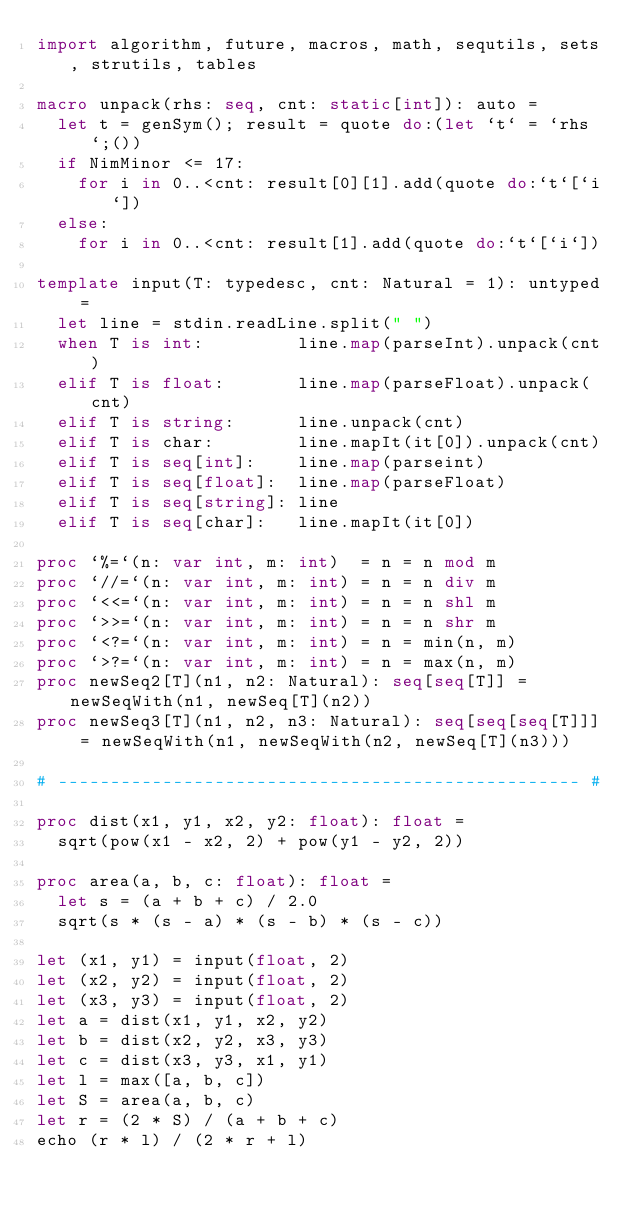<code> <loc_0><loc_0><loc_500><loc_500><_Nim_>import algorithm, future, macros, math, sequtils, sets, strutils, tables

macro unpack(rhs: seq, cnt: static[int]): auto =
  let t = genSym(); result = quote do:(let `t` = `rhs`;())
  if NimMinor <= 17:
    for i in 0..<cnt: result[0][1].add(quote do:`t`[`i`])
  else:
    for i in 0..<cnt: result[1].add(quote do:`t`[`i`])

template input(T: typedesc, cnt: Natural = 1): untyped =
  let line = stdin.readLine.split(" ")
  when T is int:         line.map(parseInt).unpack(cnt)
  elif T is float:       line.map(parseFloat).unpack(cnt)
  elif T is string:      line.unpack(cnt)
  elif T is char:        line.mapIt(it[0]).unpack(cnt)
  elif T is seq[int]:    line.map(parseint)
  elif T is seq[float]:  line.map(parseFloat)
  elif T is seq[string]: line
  elif T is seq[char]:   line.mapIt(it[0])

proc `%=`(n: var int, m: int)  = n = n mod m
proc `//=`(n: var int, m: int) = n = n div m
proc `<<=`(n: var int, m: int) = n = n shl m
proc `>>=`(n: var int, m: int) = n = n shr m
proc `<?=`(n: var int, m: int) = n = min(n, m)
proc `>?=`(n: var int, m: int) = n = max(n, m)
proc newSeq2[T](n1, n2: Natural): seq[seq[T]] = newSeqWith(n1, newSeq[T](n2))
proc newSeq3[T](n1, n2, n3: Natural): seq[seq[seq[T]]] = newSeqWith(n1, newSeqWith(n2, newSeq[T](n3)))

# -------------------------------------------------- #

proc dist(x1, y1, x2, y2: float): float =
  sqrt(pow(x1 - x2, 2) + pow(y1 - y2, 2))

proc area(a, b, c: float): float =
  let s = (a + b + c) / 2.0
  sqrt(s * (s - a) * (s - b) * (s - c))

let (x1, y1) = input(float, 2)
let (x2, y2) = input(float, 2)
let (x3, y3) = input(float, 2)
let a = dist(x1, y1, x2, y2)
let b = dist(x2, y2, x3, y3)
let c = dist(x3, y3, x1, y1)
let l = max([a, b, c])
let S = area(a, b, c)
let r = (2 * S) / (a + b + c)
echo (r * l) / (2 * r + l)</code> 